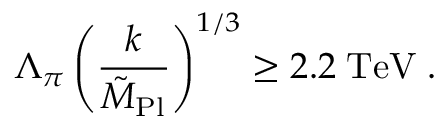<formula> <loc_0><loc_0><loc_500><loc_500>\Lambda _ { \pi } \left ( { \frac { k } { \tilde { M } _ { P l } } } \right ) ^ { 1 / 3 } \geq 2 . 2 \, T e V \, .</formula> 